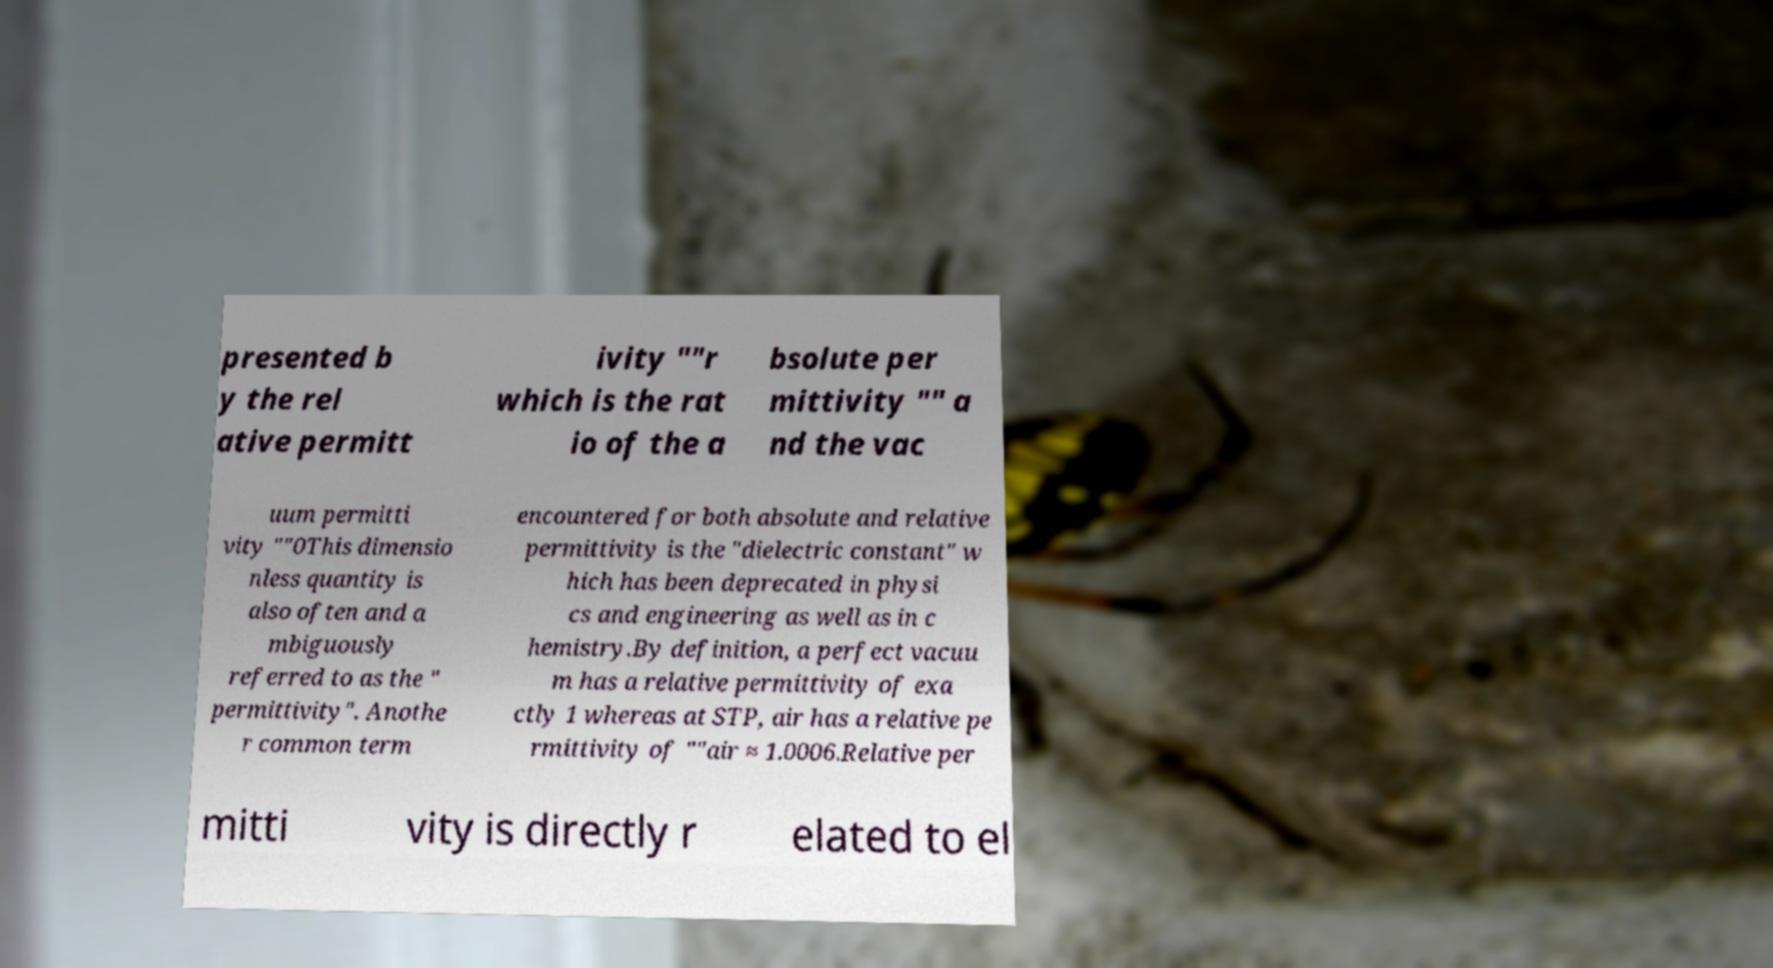There's text embedded in this image that I need extracted. Can you transcribe it verbatim? presented b y the rel ative permitt ivity ""r which is the rat io of the a bsolute per mittivity "" a nd the vac uum permitti vity ""0This dimensio nless quantity is also often and a mbiguously referred to as the " permittivity". Anothe r common term encountered for both absolute and relative permittivity is the "dielectric constant" w hich has been deprecated in physi cs and engineering as well as in c hemistry.By definition, a perfect vacuu m has a relative permittivity of exa ctly 1 whereas at STP, air has a relative pe rmittivity of ""air ≈ 1.0006.Relative per mitti vity is directly r elated to el 